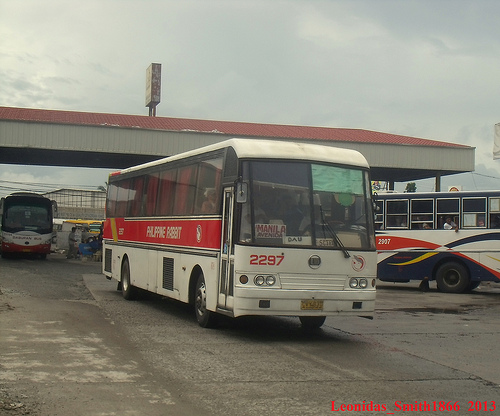<image>
Is there a man behind the bus? Yes. From this viewpoint, the man is positioned behind the bus, with the bus partially or fully occluding the man. 